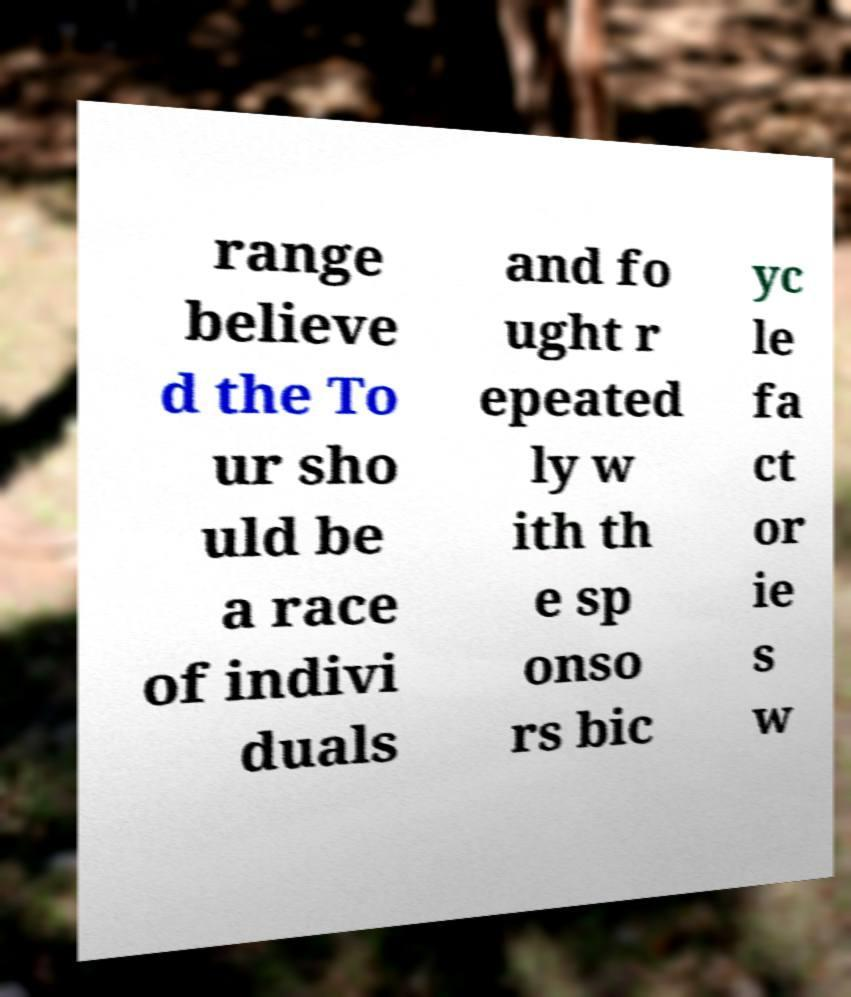For documentation purposes, I need the text within this image transcribed. Could you provide that? range believe d the To ur sho uld be a race of indivi duals and fo ught r epeated ly w ith th e sp onso rs bic yc le fa ct or ie s w 